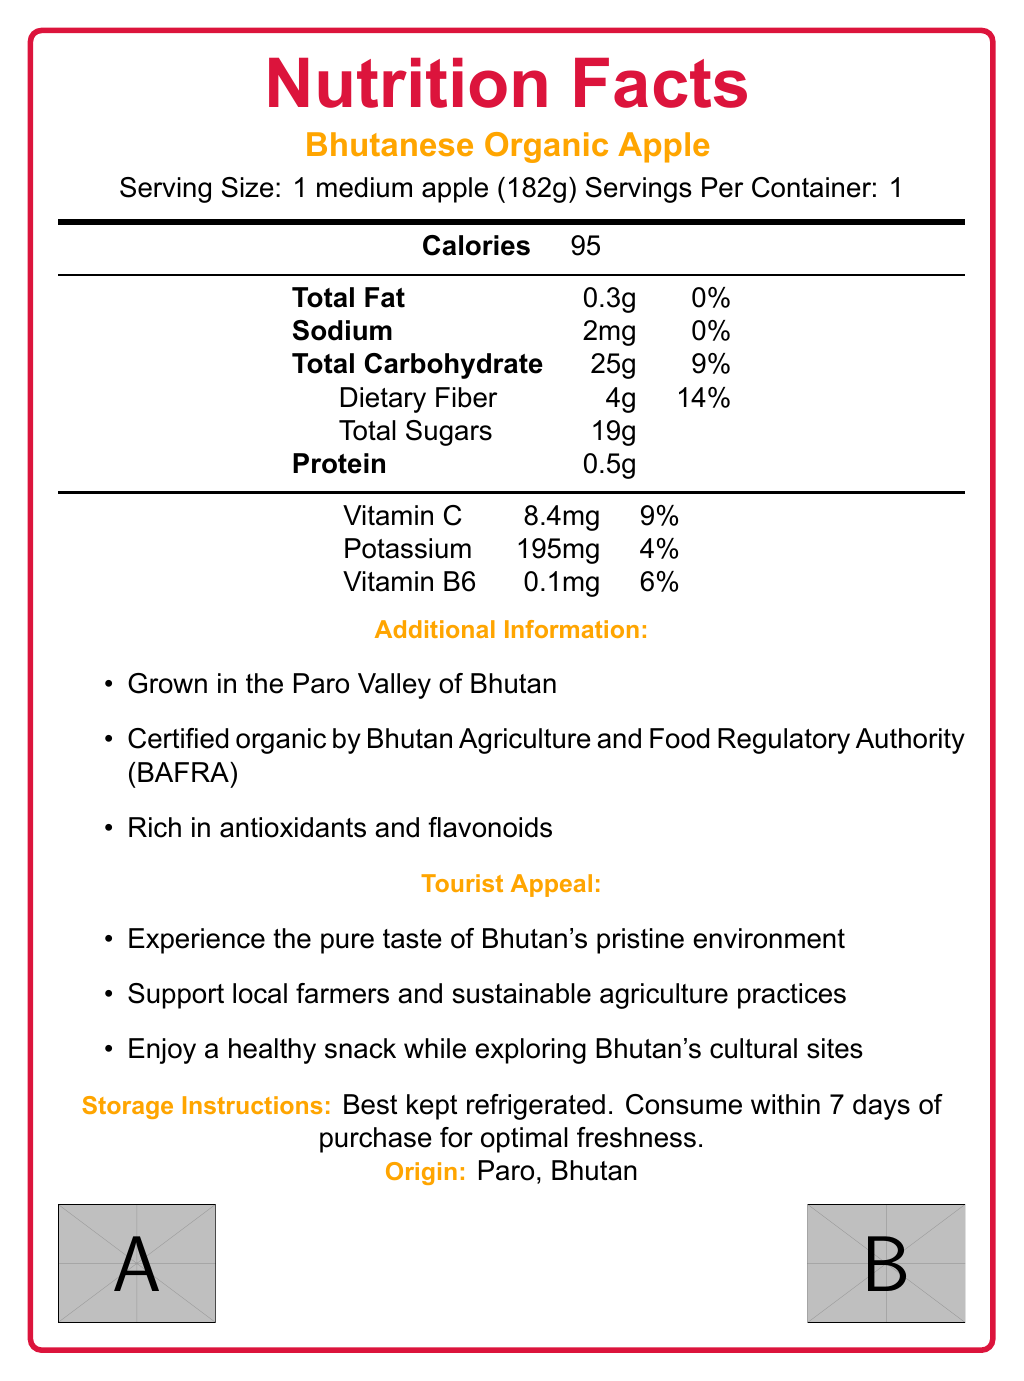what is the serving size of a Bhutanese organic apple? The document specifies the serving size as 1 medium apple (182g).
Answer: 1 medium apple (182g) how many calories are in one serving of the Bhutanese organic apple? The document lists the calorie content as 95 calories per serving.
Answer: 95 how much potassium does one Bhutanese organic apple contain? The document states that one Bhutanese organic apple contains 195mg of potassium.
Answer: 195mg is the Bhutanese organic apple rich in dietary fiber? The document states that one medium apple contains 4g of dietary fiber, which is 14% of the daily value, indicating it is rich in dietary fiber.
Answer: Yes where is the Bhutanese organic apple grown? The document mentions that the apple is grown in the Paro Valley of Bhutan.
Answer: Paro, Bhutan what percentage of the daily value of Vitamin C does one Bhutanese organic apple provide? The document indicates that one apple provides 9% of the daily value of Vitamin C.
Answer: 9% how much total fat is in one serving of the Bhutanese organic apple? The document shows that one medium apple contains 0.3g of total fat.
Answer: 0.3g what information is provided about the origin of the Bhutanese organic apple? The document states the origin as Paro, Bhutan, and mentions the certification by BAFRA.
Answer: The apple is grown in the Paro Valley of Bhutan and it is certified organic by the Bhutan Agriculture and Food Regulatory Authority (BAFRA). how frequently should the Bhutanese organic apple be consumed for optimal freshness after purchase? The document advises consuming the apple within 7 days of purchase for optimal freshness.
Answer: Within 7 days how can you best store the Bhutanese organic apple to maintain its freshness? The document recommends keeping the apple refrigerated for maintaining freshness.
Answer: Best kept refrigerated what are some benefits of consuming the Bhutanese organic apple according to the document? The document lists these benefits in the tourist appeal section.
Answer: Experience the pure taste of Bhutan's pristine environment, support local farmers and sustainable agriculture practices, enjoy a healthy snack while exploring Bhutan's cultural sites. The Bhutanese organic apple is grown in which region? 
A. Thimphu 
B. Paro 
C. Punakha 
D. Haa The document specifies that the apple is grown in the Paro Valley of Bhutan.
Answer: B What is one of the key benefits of Bhutanese organic apples according to the document?
I. High in protein
II. Rich in antioxidants and flavonoids
III. Contains high fat content
IV. Low in calories The document mentions that the apple is rich in antioxidants and flavonoids.
Answer: II Is the Bhutanese organic apple certified by any authority? According to the document, it is certified organic by the Bhutan Agriculture and Food Regulatory Authority (BAFRA).
Answer: Yes why would a tourist be interested in trying the Bhutanese organic apple? The tourist appeal section highlights these reasons as potential benefits for tourists.
Answer: Tourists might be interested because they can experience the pure taste of Bhutan's pristine environment, support local farmers and sustainable agriculture practices, and enjoy a healthy snack while exploring Bhutan's cultural sites. what percentage of the daily value of sodium is in one Bhutanese organic apple? The document lists the sodium content as 2mg, which is 0% of the daily value.
Answer: 0% how much protein does one Bhutanese organic apple contain? The document lists the protein content as 0.5g per serving.
Answer: 0.5g can you find out how to cook Bhutanese organic apple from the document? The document only provides nutritional information, storage instructions, and tourist appeal; it does not provide cooking information.
Answer: Not enough information summarize the main idea of the document. The document mainly focuses on the nutritional value and benefits of the Bhutanese organic apple, as well as providing additional information that would appeal to tourists and consumers.
Answer: The document provides the nutrition facts label for a Bhutanese organic apple, including its serving size, calorie content, and vitamin/mineral content. It highlights that the apple is grown organically in Paro, Bhutan, and offers additional benefits like supporting local farmers, sustainability, and being rich in antioxidants. The document also advises on the storage and best consumption practices for the apple to maintain its freshness. 